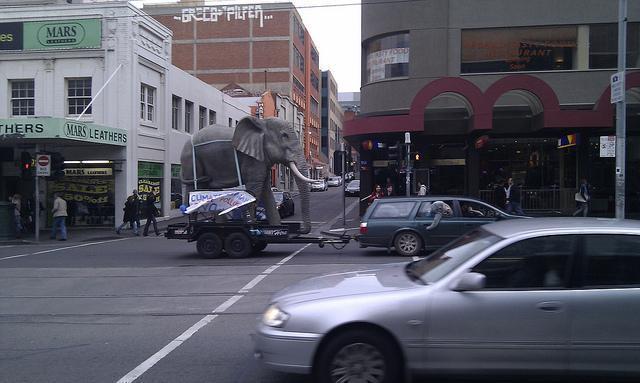How many cars are in the picture?
Give a very brief answer. 2. How many benches are there?
Give a very brief answer. 0. 